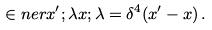<formula> <loc_0><loc_0><loc_500><loc_500>\in n e r { x ^ { \prime } ; \lambda } { x ; \lambda } = \delta ^ { 4 } ( x ^ { \prime } - x ) \, .</formula> 